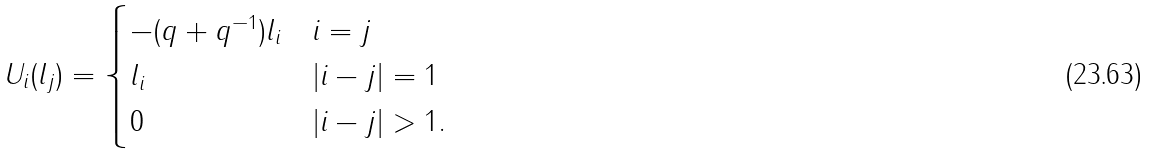<formula> <loc_0><loc_0><loc_500><loc_500>U _ { i } ( l _ { j } ) = \begin{cases} - ( q + q ^ { - 1 } ) l _ { i } & i = j \\ l _ { i } & | i - j | = 1 \\ 0 & | i - j | > 1 . \end{cases}</formula> 